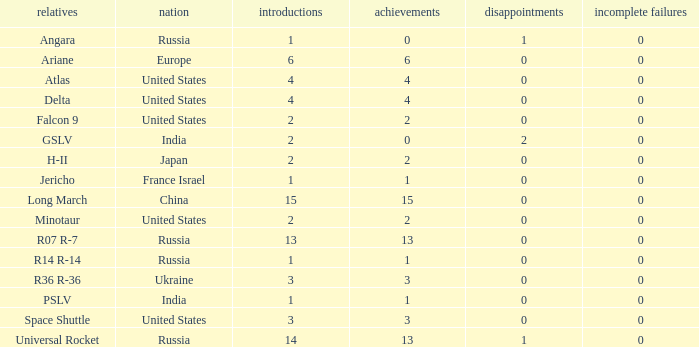What is the number of failure for the country of Russia, and a Family of r14 r-14, and a Partial failures smaller than 0? 0.0. 